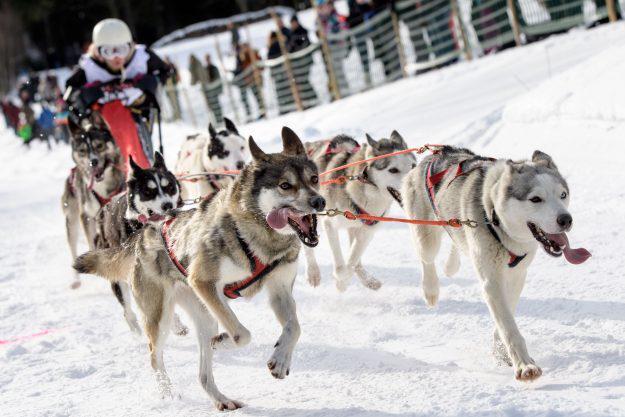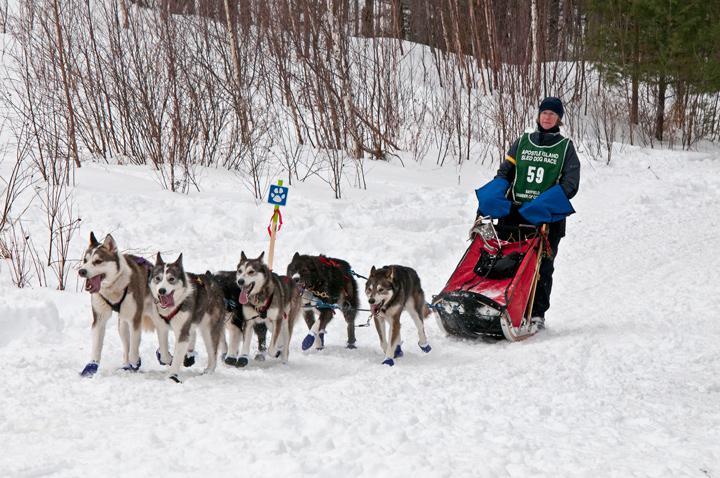The first image is the image on the left, the second image is the image on the right. Examine the images to the left and right. Is the description "In at least one image there are are at least five huskey moving left with doggy boots covering their paws." accurate? Answer yes or no. Yes. The first image is the image on the left, the second image is the image on the right. Assess this claim about the two images: "The sled dogs in the images are running in the same general direction.". Correct or not? Answer yes or no. No. 